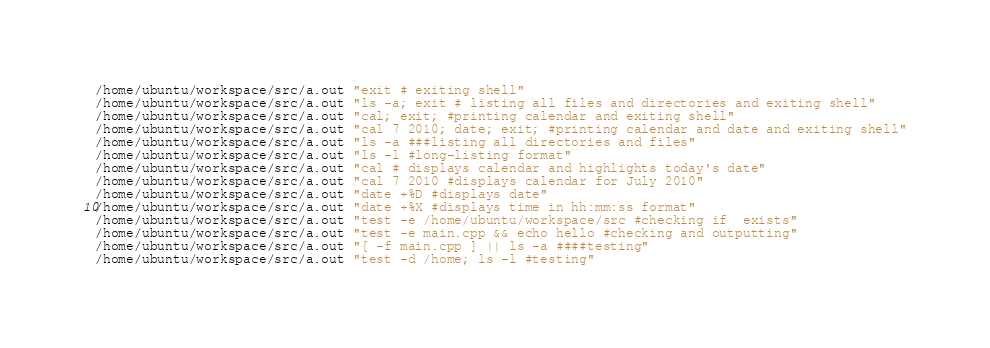<code> <loc_0><loc_0><loc_500><loc_500><_Bash_>/home/ubuntu/workspace/src/a.out "exit # exiting shell"
/home/ubuntu/workspace/src/a.out "ls -a; exit # listing all files and directories and exiting shell"
/home/ubuntu/workspace/src/a.out "cal; exit; #printing calendar and exiting shell"
/home/ubuntu/workspace/src/a.out "cal 7 2010; date; exit; #printing calendar and date and exiting shell"
/home/ubuntu/workspace/src/a.out "ls -a ###listing all directories and files"
/home/ubuntu/workspace/src/a.out "ls -l #long-listing format"
/home/ubuntu/workspace/src/a.out "cal # displays calendar and highlights today's date"
/home/ubuntu/workspace/src/a.out "cal 7 2010 #displays calendar for July 2010"
/home/ubuntu/workspace/src/a.out "date +%D #displays date"
/home/ubuntu/workspace/src/a.out "date +%X #displays time in hh:mm:ss format"
/home/ubuntu/workspace/src/a.out "test -e /home/ubuntu/workspace/src #checking if  exists"
/home/ubuntu/workspace/src/a.out "test -e main.cpp && echo hello #checking and outputting"
/home/ubuntu/workspace/src/a.out "[ -f main.cpp ] || ls -a ####testing"
/home/ubuntu/workspace/src/a.out "test -d /home; ls -l #testing"</code> 